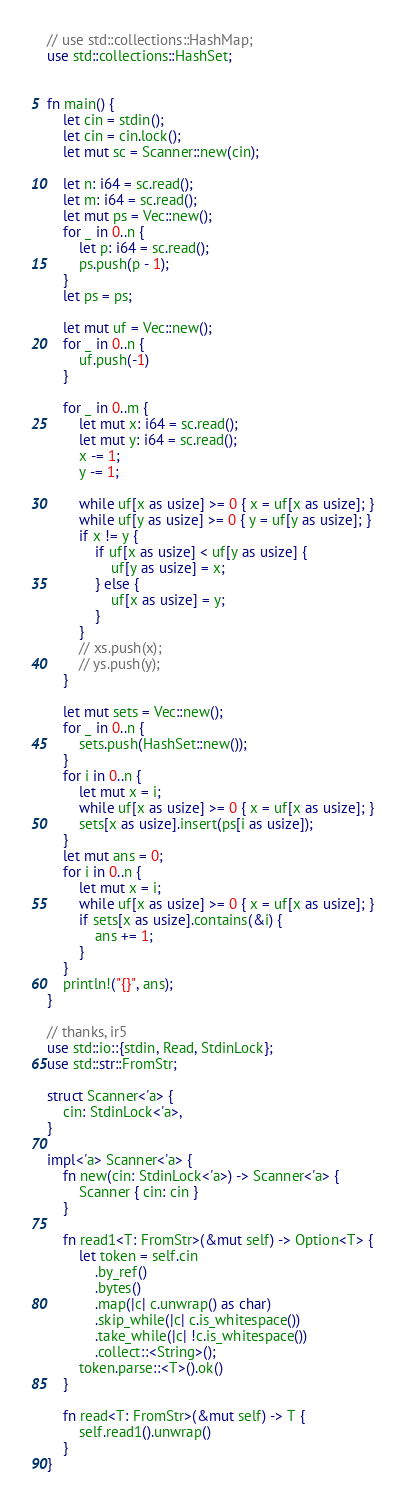<code> <loc_0><loc_0><loc_500><loc_500><_Rust_>// use std::collections::HashMap;
use std::collections::HashSet;


fn main() {
    let cin = stdin();
    let cin = cin.lock();
    let mut sc = Scanner::new(cin);

    let n: i64 = sc.read();
    let m: i64 = sc.read();
    let mut ps = Vec::new();
    for _ in 0..n {
        let p: i64 = sc.read();
        ps.push(p - 1);
    }
    let ps = ps;

    let mut uf = Vec::new();
    for _ in 0..n {
        uf.push(-1)
    }

    for _ in 0..m {
        let mut x: i64 = sc.read();
        let mut y: i64 = sc.read();
        x -= 1;
        y -= 1;

        while uf[x as usize] >= 0 { x = uf[x as usize]; }
        while uf[y as usize] >= 0 { y = uf[y as usize]; }
        if x != y {
            if uf[x as usize] < uf[y as usize] {
                uf[y as usize] = x;
            } else {
                uf[x as usize] = y;
            }
        }
        // xs.push(x);
        // ys.push(y);
    }

    let mut sets = Vec::new();
    for _ in 0..n {
        sets.push(HashSet::new());
    }
    for i in 0..n {
        let mut x = i;
        while uf[x as usize] >= 0 { x = uf[x as usize]; }
        sets[x as usize].insert(ps[i as usize]);
    }
    let mut ans = 0;
    for i in 0..n {
        let mut x = i;
        while uf[x as usize] >= 0 { x = uf[x as usize]; }
        if sets[x as usize].contains(&i) {
            ans += 1;
        }
    }
    println!("{}", ans);
}

// thanks, ir5
use std::io::{stdin, Read, StdinLock};
use std::str::FromStr;

struct Scanner<'a> {
    cin: StdinLock<'a>,
}

impl<'a> Scanner<'a> {
    fn new(cin: StdinLock<'a>) -> Scanner<'a> {
        Scanner { cin: cin }
    }

    fn read1<T: FromStr>(&mut self) -> Option<T> {
        let token = self.cin
            .by_ref()
            .bytes()
            .map(|c| c.unwrap() as char)
            .skip_while(|c| c.is_whitespace())
            .take_while(|c| !c.is_whitespace())
            .collect::<String>();
        token.parse::<T>().ok()
    }

    fn read<T: FromStr>(&mut self) -> T {
        self.read1().unwrap()
    }
}
</code> 